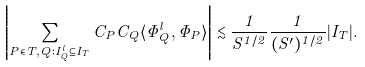<formula> <loc_0><loc_0><loc_500><loc_500>\left | \sum _ { P \in T , Q \colon I ^ { l } _ { Q } \subseteq I _ { T } } C _ { P } C _ { Q } \langle \widetilde { \Phi } _ { Q } ^ { l } , \Phi _ { P } \rangle \right | \lesssim \frac { 1 } { S ^ { 1 / 2 } } \frac { 1 } { ( S ^ { \prime } ) ^ { 1 / 2 } } | I _ { T } | .</formula> 